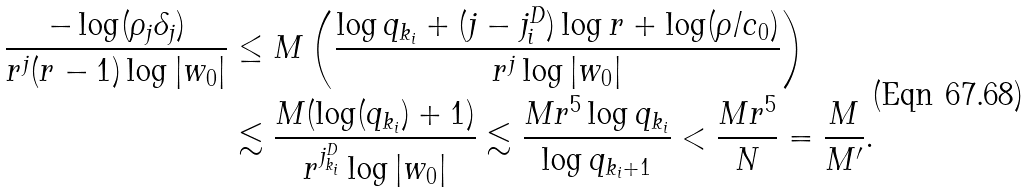Convert formula to latex. <formula><loc_0><loc_0><loc_500><loc_500>\frac { - \log ( \rho _ { j } \delta _ { j } ) } { r ^ { j } ( r - 1 ) \log | w _ { 0 } | } & \leq M \left ( \frac { \log q _ { k _ { i } } + ( j - j ^ { D } _ { i } ) \log r + \log ( \rho / c _ { 0 } ) } { r ^ { j } \log | w _ { 0 } | } \right ) \\ & \lesssim \frac { M ( \log ( q _ { k _ { i } } ) + 1 ) } { r ^ { j ^ { D } _ { k _ { i } } } \log | w _ { 0 } | } \lesssim \frac { M r ^ { 5 } \log q _ { k _ { i } } } { \log q _ { k _ { i } + 1 } } < \frac { M r ^ { 5 } } { N } = \frac { M } { M ^ { \prime } } .</formula> 